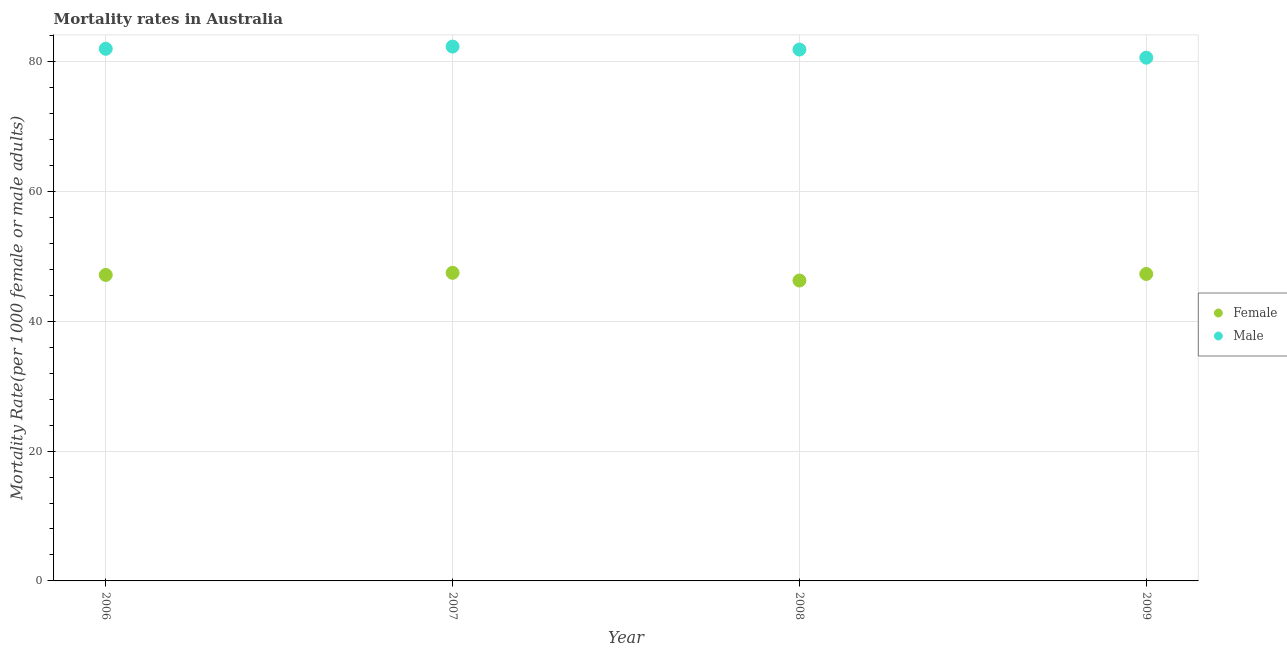Is the number of dotlines equal to the number of legend labels?
Keep it short and to the point. Yes. What is the male mortality rate in 2006?
Offer a terse response. 81.97. Across all years, what is the maximum female mortality rate?
Make the answer very short. 47.46. Across all years, what is the minimum male mortality rate?
Provide a short and direct response. 80.6. In which year was the male mortality rate minimum?
Give a very brief answer. 2009. What is the total female mortality rate in the graph?
Your answer should be compact. 188.14. What is the difference between the female mortality rate in 2007 and that in 2008?
Your response must be concise. 1.18. What is the difference between the female mortality rate in 2007 and the male mortality rate in 2006?
Give a very brief answer. -34.51. What is the average male mortality rate per year?
Keep it short and to the point. 81.68. In the year 2008, what is the difference between the female mortality rate and male mortality rate?
Ensure brevity in your answer.  -35.58. In how many years, is the male mortality rate greater than 16?
Make the answer very short. 4. What is the ratio of the female mortality rate in 2006 to that in 2007?
Your answer should be compact. 0.99. Is the female mortality rate in 2008 less than that in 2009?
Provide a succinct answer. Yes. What is the difference between the highest and the second highest male mortality rate?
Provide a short and direct response. 0.34. What is the difference between the highest and the lowest female mortality rate?
Offer a terse response. 1.18. Is the sum of the male mortality rate in 2007 and 2009 greater than the maximum female mortality rate across all years?
Offer a terse response. Yes. How many dotlines are there?
Keep it short and to the point. 2. What is the difference between two consecutive major ticks on the Y-axis?
Your response must be concise. 20. Are the values on the major ticks of Y-axis written in scientific E-notation?
Provide a short and direct response. No. Does the graph contain any zero values?
Your answer should be very brief. No. What is the title of the graph?
Your answer should be compact. Mortality rates in Australia. What is the label or title of the X-axis?
Provide a succinct answer. Year. What is the label or title of the Y-axis?
Give a very brief answer. Mortality Rate(per 1000 female or male adults). What is the Mortality Rate(per 1000 female or male adults) in Female in 2006?
Your answer should be very brief. 47.13. What is the Mortality Rate(per 1000 female or male adults) in Male in 2006?
Offer a very short reply. 81.97. What is the Mortality Rate(per 1000 female or male adults) in Female in 2007?
Offer a terse response. 47.46. What is the Mortality Rate(per 1000 female or male adults) of Male in 2007?
Ensure brevity in your answer.  82.31. What is the Mortality Rate(per 1000 female or male adults) in Female in 2008?
Make the answer very short. 46.27. What is the Mortality Rate(per 1000 female or male adults) of Male in 2008?
Your response must be concise. 81.85. What is the Mortality Rate(per 1000 female or male adults) of Female in 2009?
Offer a terse response. 47.28. What is the Mortality Rate(per 1000 female or male adults) in Male in 2009?
Offer a terse response. 80.6. Across all years, what is the maximum Mortality Rate(per 1000 female or male adults) in Female?
Offer a very short reply. 47.46. Across all years, what is the maximum Mortality Rate(per 1000 female or male adults) of Male?
Offer a terse response. 82.31. Across all years, what is the minimum Mortality Rate(per 1000 female or male adults) in Female?
Your answer should be very brief. 46.27. Across all years, what is the minimum Mortality Rate(per 1000 female or male adults) in Male?
Your response must be concise. 80.6. What is the total Mortality Rate(per 1000 female or male adults) of Female in the graph?
Give a very brief answer. 188.14. What is the total Mortality Rate(per 1000 female or male adults) of Male in the graph?
Your answer should be compact. 326.73. What is the difference between the Mortality Rate(per 1000 female or male adults) of Female in 2006 and that in 2007?
Keep it short and to the point. -0.33. What is the difference between the Mortality Rate(per 1000 female or male adults) of Male in 2006 and that in 2007?
Provide a succinct answer. -0.34. What is the difference between the Mortality Rate(per 1000 female or male adults) of Female in 2006 and that in 2008?
Give a very brief answer. 0.86. What is the difference between the Mortality Rate(per 1000 female or male adults) in Male in 2006 and that in 2008?
Offer a terse response. 0.11. What is the difference between the Mortality Rate(per 1000 female or male adults) of Female in 2006 and that in 2009?
Make the answer very short. -0.15. What is the difference between the Mortality Rate(per 1000 female or male adults) of Male in 2006 and that in 2009?
Your response must be concise. 1.37. What is the difference between the Mortality Rate(per 1000 female or male adults) in Female in 2007 and that in 2008?
Your response must be concise. 1.18. What is the difference between the Mortality Rate(per 1000 female or male adults) of Male in 2007 and that in 2008?
Your response must be concise. 0.46. What is the difference between the Mortality Rate(per 1000 female or male adults) of Female in 2007 and that in 2009?
Your response must be concise. 0.17. What is the difference between the Mortality Rate(per 1000 female or male adults) in Male in 2007 and that in 2009?
Give a very brief answer. 1.71. What is the difference between the Mortality Rate(per 1000 female or male adults) of Female in 2008 and that in 2009?
Ensure brevity in your answer.  -1.01. What is the difference between the Mortality Rate(per 1000 female or male adults) of Male in 2008 and that in 2009?
Your answer should be compact. 1.25. What is the difference between the Mortality Rate(per 1000 female or male adults) in Female in 2006 and the Mortality Rate(per 1000 female or male adults) in Male in 2007?
Provide a short and direct response. -35.18. What is the difference between the Mortality Rate(per 1000 female or male adults) of Female in 2006 and the Mortality Rate(per 1000 female or male adults) of Male in 2008?
Your response must be concise. -34.72. What is the difference between the Mortality Rate(per 1000 female or male adults) in Female in 2006 and the Mortality Rate(per 1000 female or male adults) in Male in 2009?
Your answer should be very brief. -33.47. What is the difference between the Mortality Rate(per 1000 female or male adults) of Female in 2007 and the Mortality Rate(per 1000 female or male adults) of Male in 2008?
Provide a succinct answer. -34.4. What is the difference between the Mortality Rate(per 1000 female or male adults) in Female in 2007 and the Mortality Rate(per 1000 female or male adults) in Male in 2009?
Offer a very short reply. -33.14. What is the difference between the Mortality Rate(per 1000 female or male adults) of Female in 2008 and the Mortality Rate(per 1000 female or male adults) of Male in 2009?
Ensure brevity in your answer.  -34.33. What is the average Mortality Rate(per 1000 female or male adults) of Female per year?
Your response must be concise. 47.04. What is the average Mortality Rate(per 1000 female or male adults) of Male per year?
Provide a succinct answer. 81.68. In the year 2006, what is the difference between the Mortality Rate(per 1000 female or male adults) in Female and Mortality Rate(per 1000 female or male adults) in Male?
Your answer should be very brief. -34.84. In the year 2007, what is the difference between the Mortality Rate(per 1000 female or male adults) in Female and Mortality Rate(per 1000 female or male adults) in Male?
Make the answer very short. -34.85. In the year 2008, what is the difference between the Mortality Rate(per 1000 female or male adults) in Female and Mortality Rate(per 1000 female or male adults) in Male?
Give a very brief answer. -35.58. In the year 2009, what is the difference between the Mortality Rate(per 1000 female or male adults) in Female and Mortality Rate(per 1000 female or male adults) in Male?
Give a very brief answer. -33.32. What is the ratio of the Mortality Rate(per 1000 female or male adults) in Female in 2006 to that in 2007?
Make the answer very short. 0.99. What is the ratio of the Mortality Rate(per 1000 female or male adults) in Male in 2006 to that in 2007?
Offer a very short reply. 1. What is the ratio of the Mortality Rate(per 1000 female or male adults) in Female in 2006 to that in 2008?
Offer a very short reply. 1.02. What is the ratio of the Mortality Rate(per 1000 female or male adults) in Male in 2006 to that in 2009?
Your answer should be compact. 1.02. What is the ratio of the Mortality Rate(per 1000 female or male adults) of Female in 2007 to that in 2008?
Offer a very short reply. 1.03. What is the ratio of the Mortality Rate(per 1000 female or male adults) of Male in 2007 to that in 2008?
Make the answer very short. 1.01. What is the ratio of the Mortality Rate(per 1000 female or male adults) of Male in 2007 to that in 2009?
Offer a terse response. 1.02. What is the ratio of the Mortality Rate(per 1000 female or male adults) of Female in 2008 to that in 2009?
Your answer should be compact. 0.98. What is the ratio of the Mortality Rate(per 1000 female or male adults) of Male in 2008 to that in 2009?
Your answer should be very brief. 1.02. What is the difference between the highest and the second highest Mortality Rate(per 1000 female or male adults) of Female?
Your answer should be very brief. 0.17. What is the difference between the highest and the second highest Mortality Rate(per 1000 female or male adults) in Male?
Give a very brief answer. 0.34. What is the difference between the highest and the lowest Mortality Rate(per 1000 female or male adults) of Female?
Provide a succinct answer. 1.18. What is the difference between the highest and the lowest Mortality Rate(per 1000 female or male adults) of Male?
Keep it short and to the point. 1.71. 